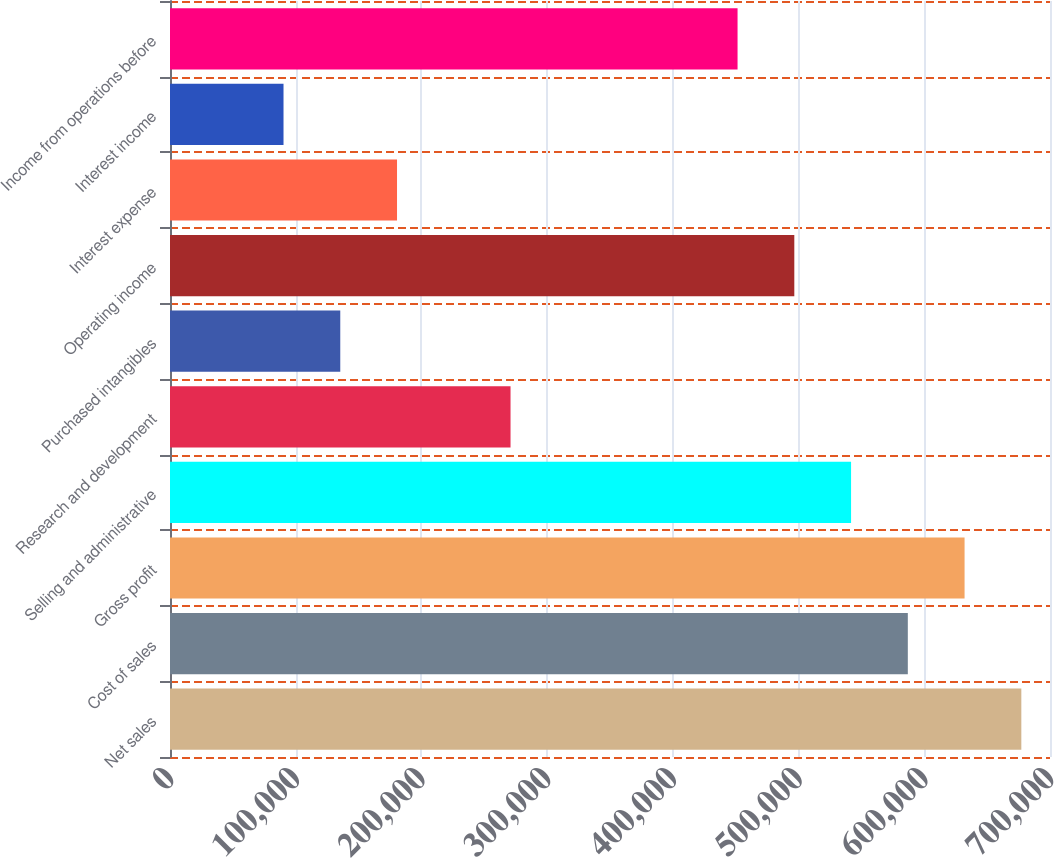Convert chart to OTSL. <chart><loc_0><loc_0><loc_500><loc_500><bar_chart><fcel>Net sales<fcel>Cost of sales<fcel>Gross profit<fcel>Selling and administrative<fcel>Research and development<fcel>Purchased intangibles<fcel>Operating income<fcel>Interest expense<fcel>Interest income<fcel>Income from operations before<nl><fcel>677197<fcel>586904<fcel>632051<fcel>541758<fcel>270879<fcel>135440<fcel>496611<fcel>180587<fcel>90293.9<fcel>451465<nl></chart> 